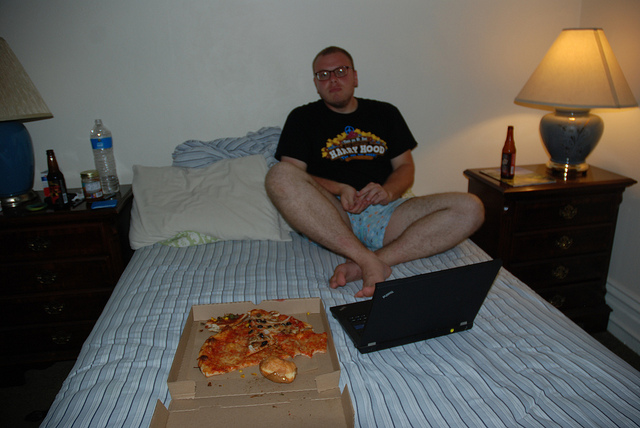Read all the text in this image. HAPPY HOOD 